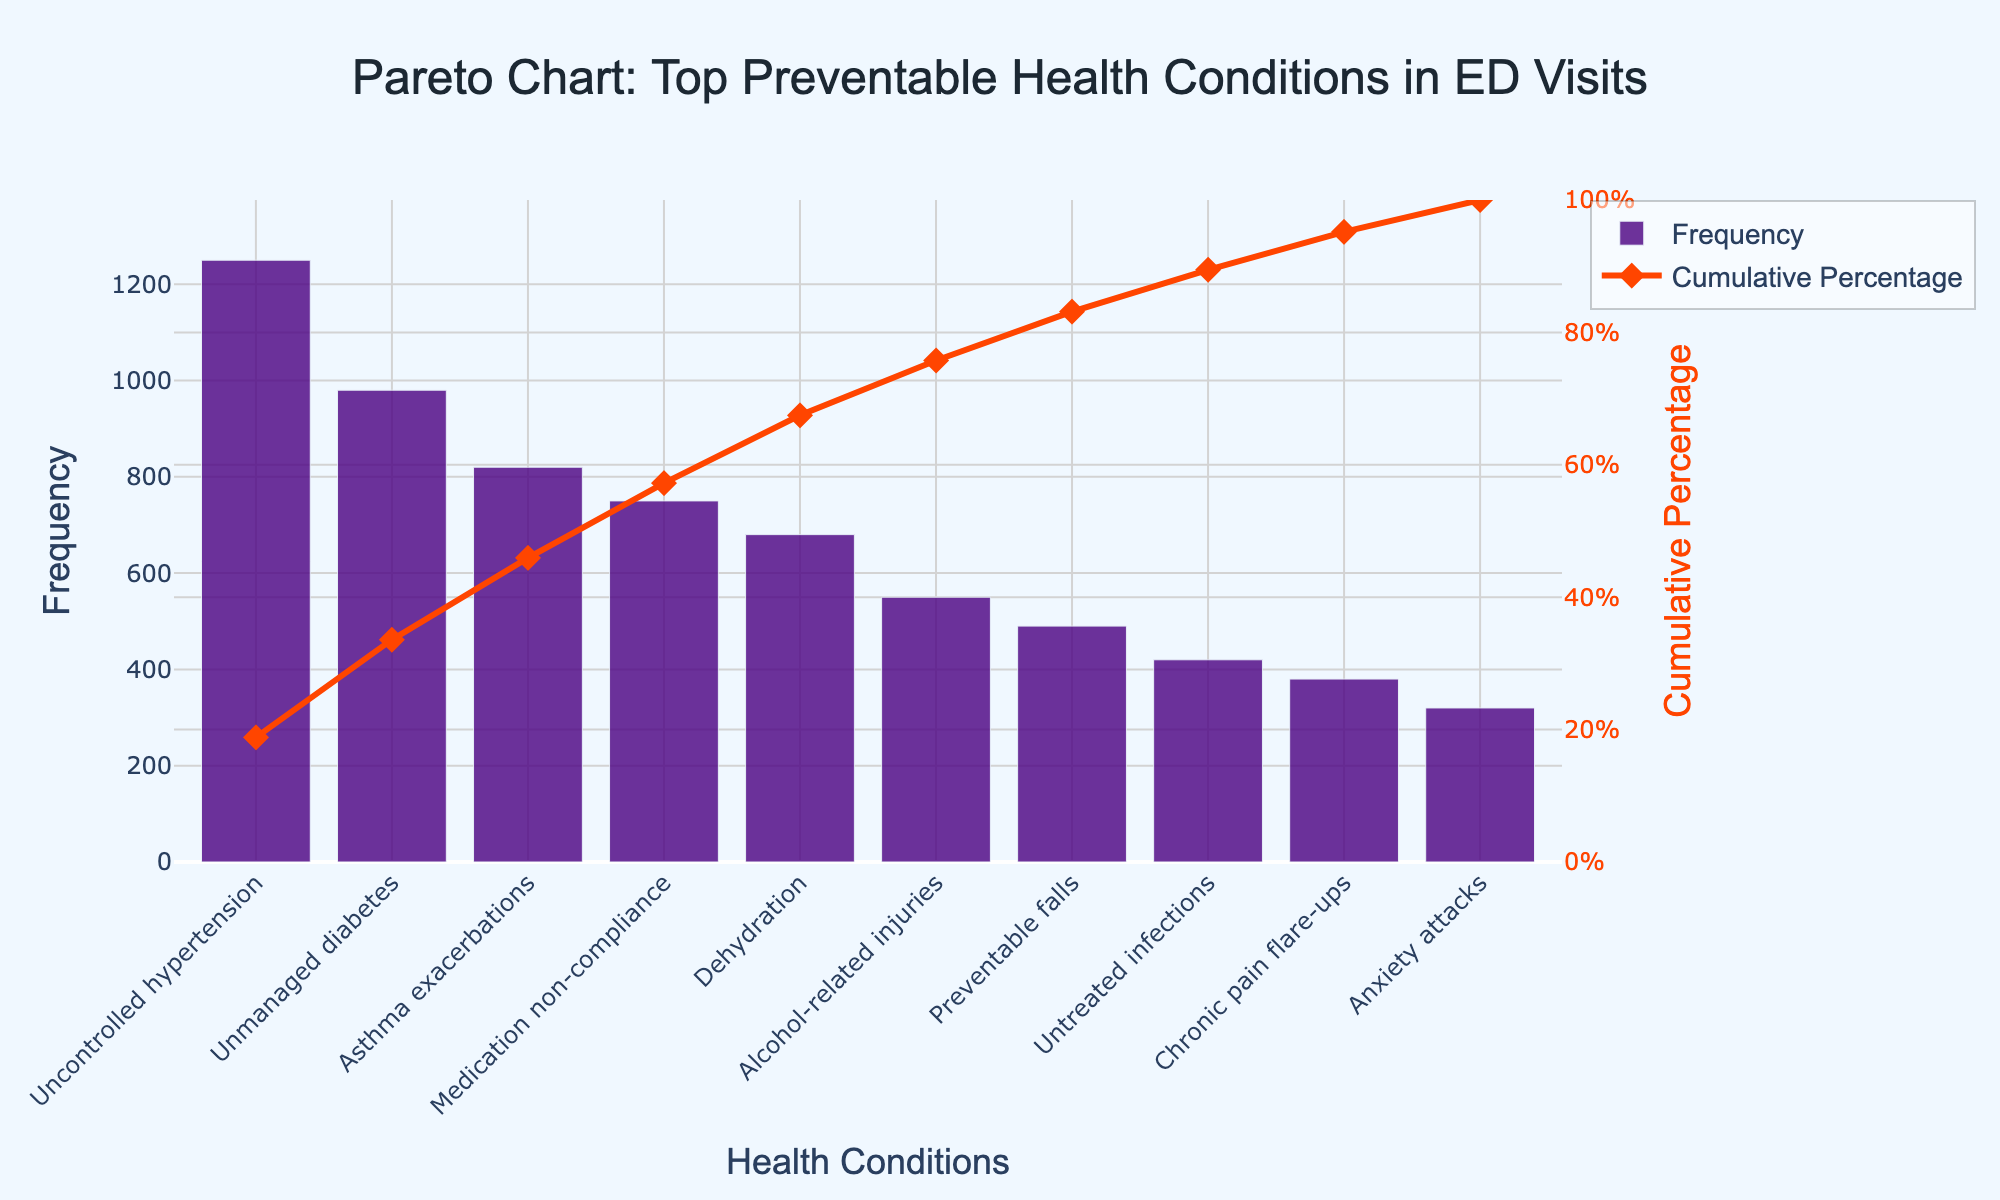what is the title of the figure? The title is prominently shown at the top of the figure. It clearly states the primary focus of the chart.
Answer: Pareto Chart: Top Preventable Health Conditions in ED Visits What health condition has the highest frequency? By looking at the bar heights, the tallest bar represents the condition with the highest frequency.
Answer: Uncontrolled hypertension How many health conditions are represented in the figure? Count the number of bars or points on the chart corresponding to different conditions.
Answer: 10 What is the cumulative percentage for unmanaged diabetes? Locate the point on the 'Cumulative Percentage' line that corresponds to unmanaged diabetes on the x-axis.
Answer: 35.10% What is the second most common health condition in emergency department visits? Identify the second tallest bar, which corresponds to the second highest frequency.
Answer: Unmanaged diabetes What is the cumulative percentage after the top three conditions? Add up the cumulative percentages up to the third condition by tracing the curve values on the y-axis.
Answer: 66.94% Compare the frequencies of asthma exacerbations and alcohol-related injuries. Which one is higher? Look at the heights of the bars for both conditions. The bar with the greater height indicates the higher frequency.
Answer: Asthma exacerbations What percentage of the total visits do the first four health conditions account for? Sum the cumulative percentages of the first four conditions from the cumulative percentage line.
Answer: 79.63% After how many conditions does the cumulative percentage exceed 80%? Look at the cumulative percentage line and pinpoint where it first crosses the 80% mark.
Answer: After 5 conditions What's the difference in frequency between chronic pain flare-ups and anxiety attacks? Subtract the frequency of anxiety attacks from the frequency of chronic pain flare-ups.
Answer: 60 